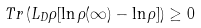<formula> <loc_0><loc_0><loc_500><loc_500>T r \left ( L _ { D } \rho [ \ln \rho ( \infty ) - \ln \rho ] \right ) \geq 0</formula> 